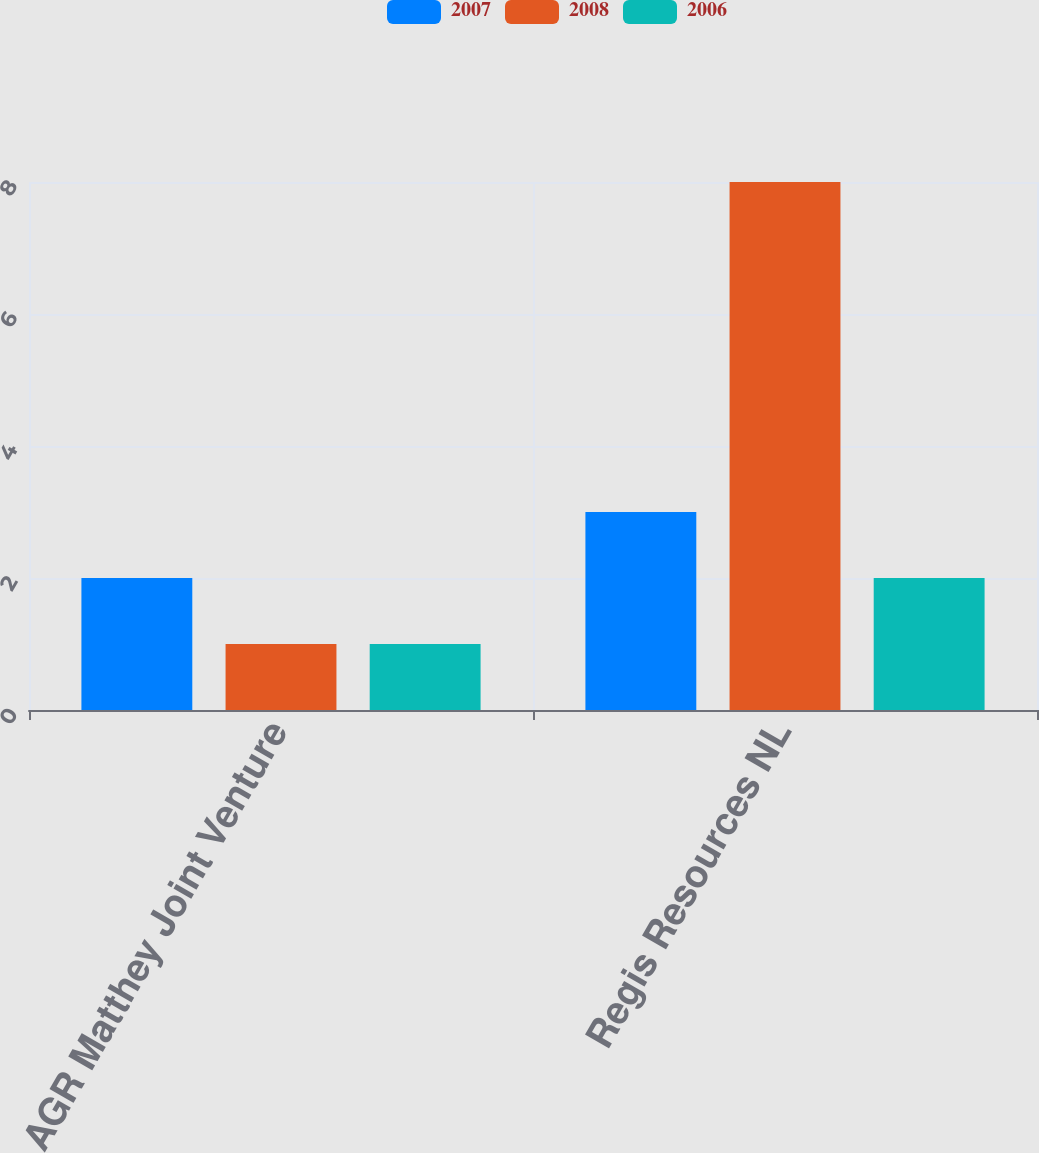<chart> <loc_0><loc_0><loc_500><loc_500><stacked_bar_chart><ecel><fcel>AGR Matthey Joint Venture<fcel>Regis Resources NL<nl><fcel>2007<fcel>2<fcel>3<nl><fcel>2008<fcel>1<fcel>8<nl><fcel>2006<fcel>1<fcel>2<nl></chart> 